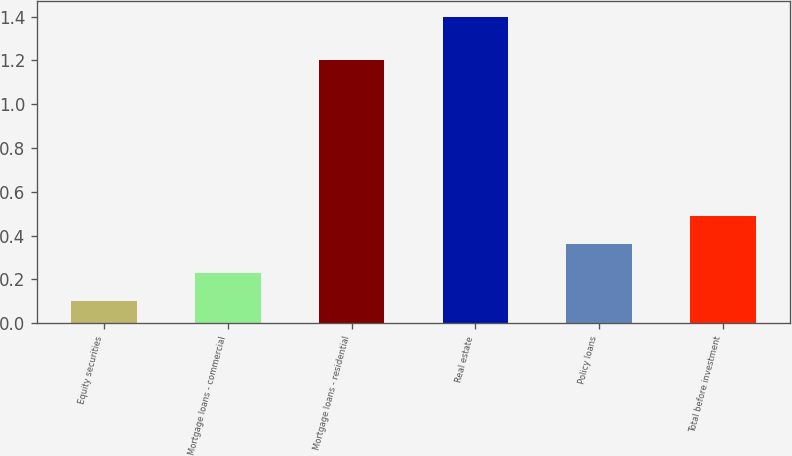<chart> <loc_0><loc_0><loc_500><loc_500><bar_chart><fcel>Equity securities<fcel>Mortgage loans - commercial<fcel>Mortgage loans - residential<fcel>Real estate<fcel>Policy loans<fcel>Total before investment<nl><fcel>0.1<fcel>0.23<fcel>1.2<fcel>1.4<fcel>0.36<fcel>0.49<nl></chart> 